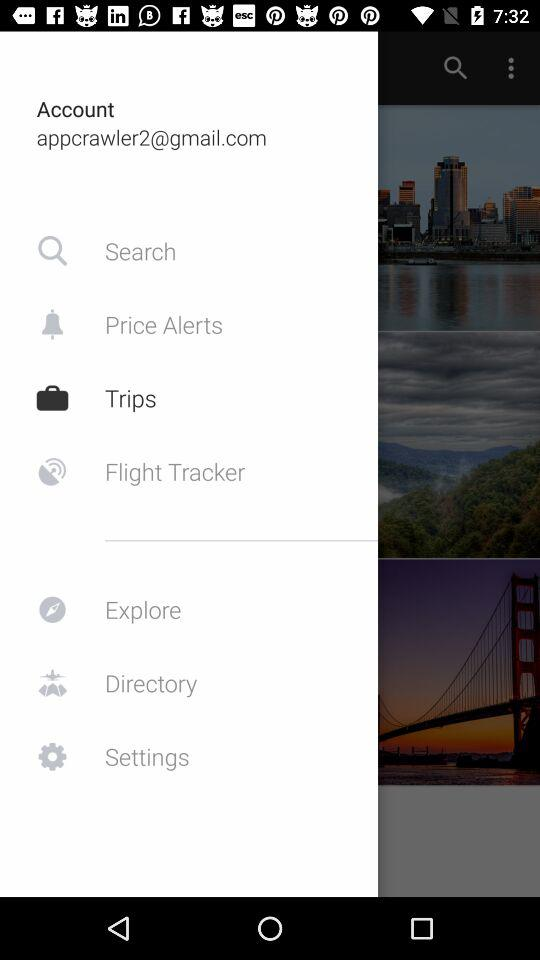What is the account email address? The account email address is appcrawler2@gmail.com. 